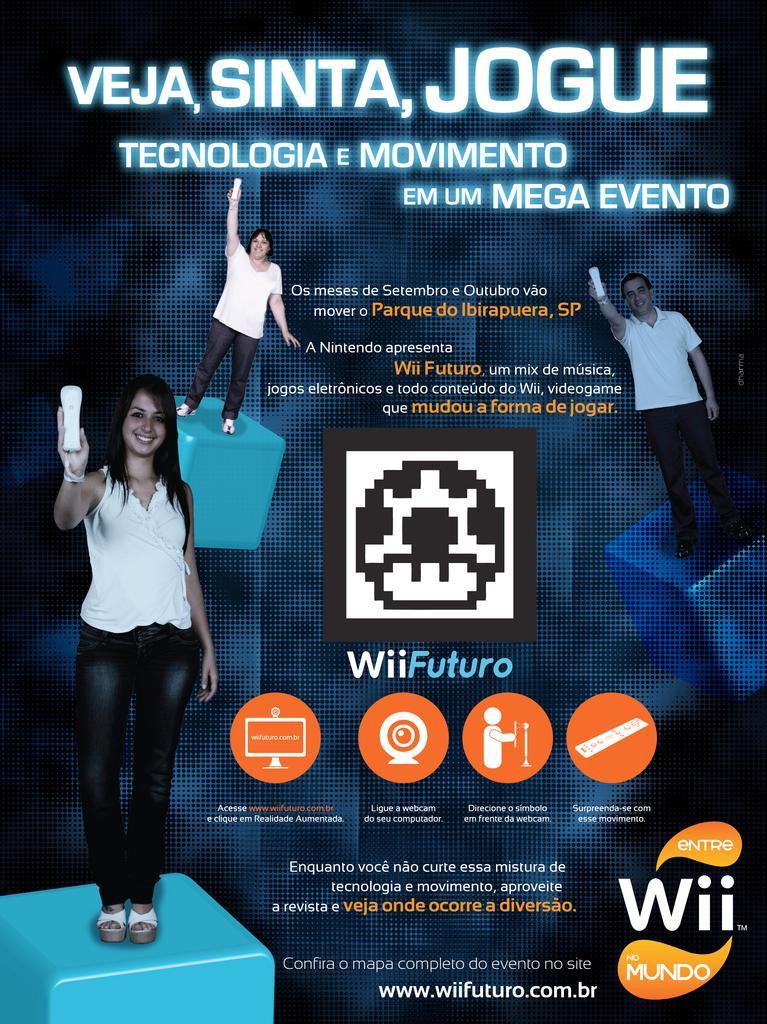Can you describe this image briefly? In this image I can see a pamphlet, in the pamphlet I can see three persons. The person in front wearing white shirt, black color pant and holding some object and I can see something written on the pamphlet. 